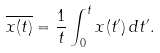Convert formula to latex. <formula><loc_0><loc_0><loc_500><loc_500>\overline { x ( t ) } = \frac { 1 } { t } \int _ { 0 } ^ { t } x ( t ^ { \prime } ) \, d t ^ { \prime } .</formula> 